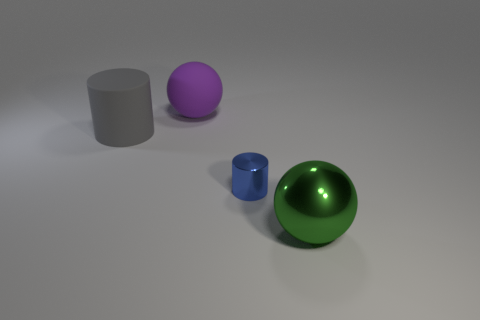The shiny cylinder has what color?
Provide a succinct answer. Blue. How many small cylinders have the same color as the big cylinder?
Your answer should be very brief. 0. There is a blue object; are there any small blue metal objects in front of it?
Provide a succinct answer. No. Is the number of gray objects that are on the right side of the tiny cylinder the same as the number of metal spheres on the right side of the green metal ball?
Your answer should be compact. Yes. Do the matte thing that is right of the gray matte cylinder and the metallic object that is left of the green metal sphere have the same size?
Keep it short and to the point. No. There is a thing on the left side of the sphere to the left of the metallic thing that is behind the big green metallic thing; what shape is it?
Your answer should be compact. Cylinder. Are there any other things that are the same material as the big purple thing?
Offer a terse response. Yes. There is a purple rubber thing that is the same shape as the green thing; what size is it?
Provide a short and direct response. Large. There is a thing that is on the right side of the purple rubber thing and behind the green shiny object; what color is it?
Give a very brief answer. Blue. Does the gray object have the same material as the large sphere that is behind the big green metal sphere?
Offer a very short reply. Yes. 